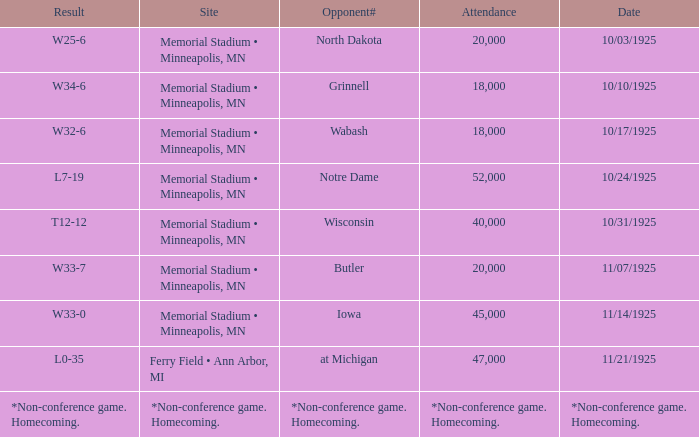Who was the opponent at the game attended by 45,000? Iowa. 